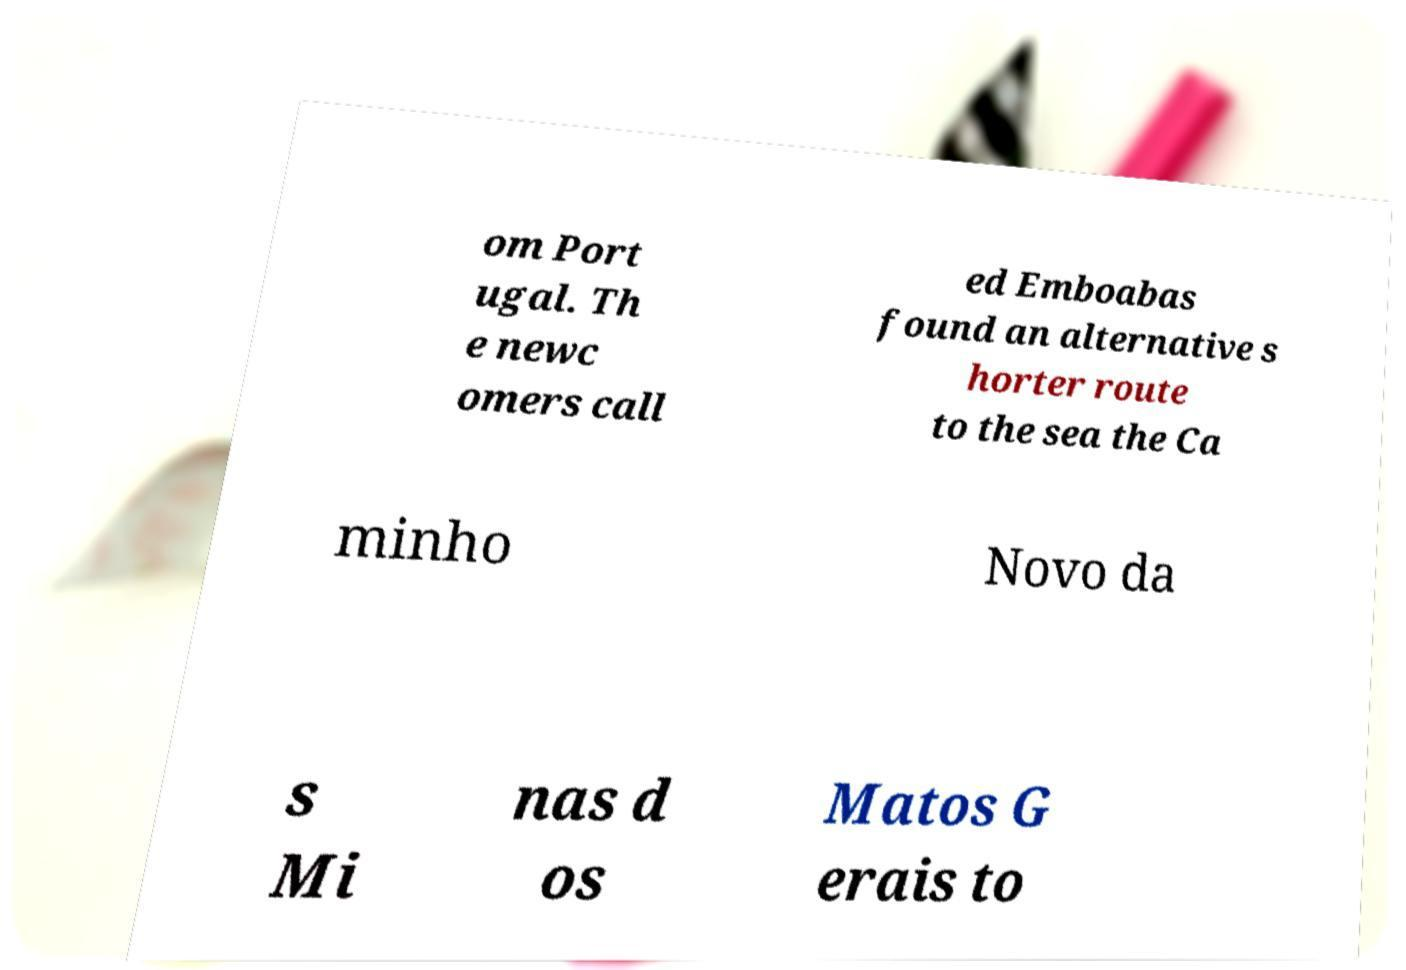What messages or text are displayed in this image? I need them in a readable, typed format. om Port ugal. Th e newc omers call ed Emboabas found an alternative s horter route to the sea the Ca minho Novo da s Mi nas d os Matos G erais to 